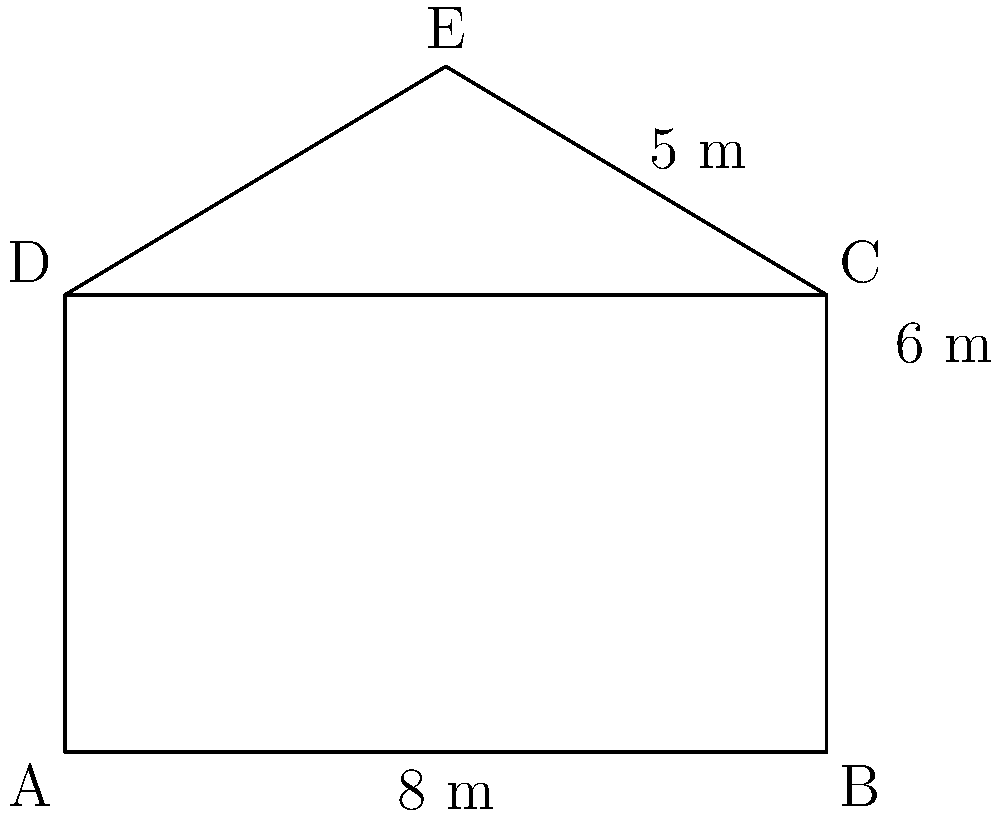A traditional Danish half-timbered house in Ribe has a rectangular facade with a triangular roof. The base of the house is 8 meters wide, the height of the rectangular part is 6 meters, and the triangular roof adds an additional 3 meters to the height at its peak. What is the total area of the house's facade in square meters? To find the total area of the house's facade, we need to calculate the area of the rectangular part and the triangular part separately, then add them together.

1. Area of the rectangular part:
   $A_{rectangle} = width \times height$
   $A_{rectangle} = 8 \text{ m} \times 6 \text{ m} = 48 \text{ m}^2$

2. Area of the triangular part:
   The base of the triangle is the same as the width of the rectangle (8 m).
   The height of the triangle is 3 m (from 6 m to 9 m).
   
   $A_{triangle} = \frac{1}{2} \times base \times height$
   $A_{triangle} = \frac{1}{2} \times 8 \text{ m} \times 3 \text{ m} = 12 \text{ m}^2$

3. Total area of the facade:
   $A_{total} = A_{rectangle} + A_{triangle}$
   $A_{total} = 48 \text{ m}^2 + 12 \text{ m}^2 = 60 \text{ m}^2$

Therefore, the total area of the house's facade is 60 square meters.
Answer: $60 \text{ m}^2$ 